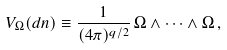<formula> <loc_0><loc_0><loc_500><loc_500>V _ { \Omega } ( d n ) \equiv \frac { 1 } { ( 4 \pi ) ^ { q / 2 } } \, \Omega \wedge \cdots \wedge \Omega \, ,</formula> 